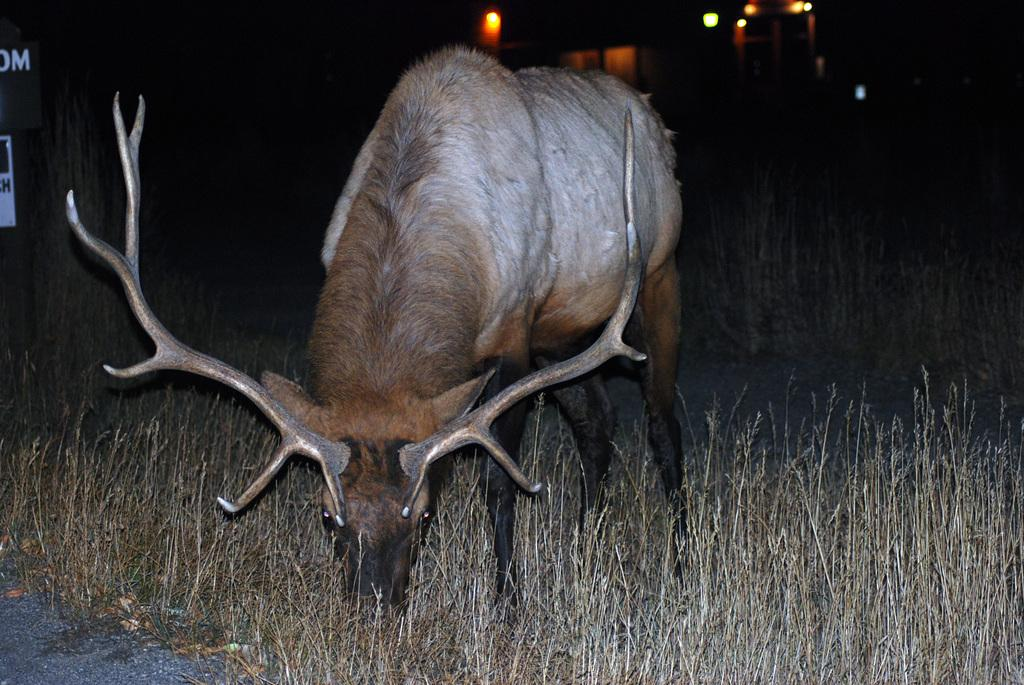What type of animal is in the image? There is an animal in the image, but the specific type cannot be determined from the provided facts. What is on the ground in the image? There is grass on the ground in the image. What is located at the top of the image? There are lights at the top of the image. How many toes does the monkey have in the image? There is no monkey present in the image, so it is not possible to determine the number of toes. What type of currency is visible in the image? There is no currency, such as a dime, present in the image. 